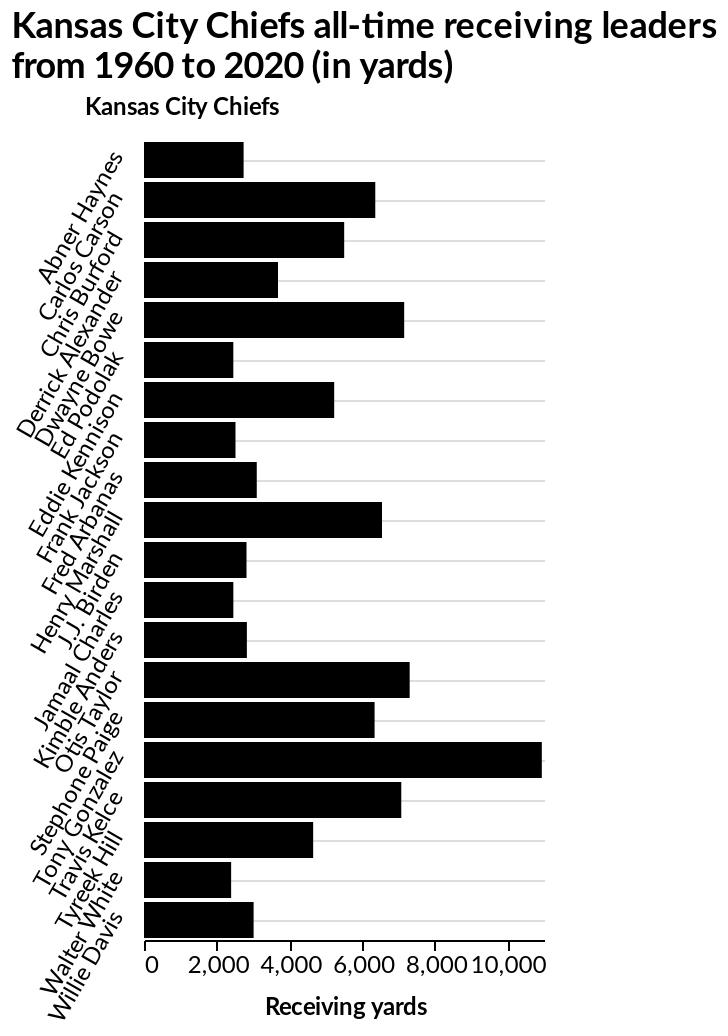<image>
What is the range of receiving yards for most Kansas City Chiefs? The range of receiving yards for most Chiefs is 2000 to 4000 yards. Describe the following image in detail Here a bar graph is titled Kansas City Chiefs all-time receiving leaders from 1960 to 2020 (in yards). The y-axis plots Kansas City Chiefs as categorical scale starting at Abner Haynes and ending at Willie Davis while the x-axis shows Receiving yards along linear scale with a minimum of 0 and a maximum of 10,000. How many Kansas City Chiefs had receiving yards within the range of 6000 to 8000 yards?  Six Kansas City Chiefs had receiving yards within the range of 6000 to 8000 yards. Who is the last receiver on the y-axis of the bar graph?  Willie Davis. 